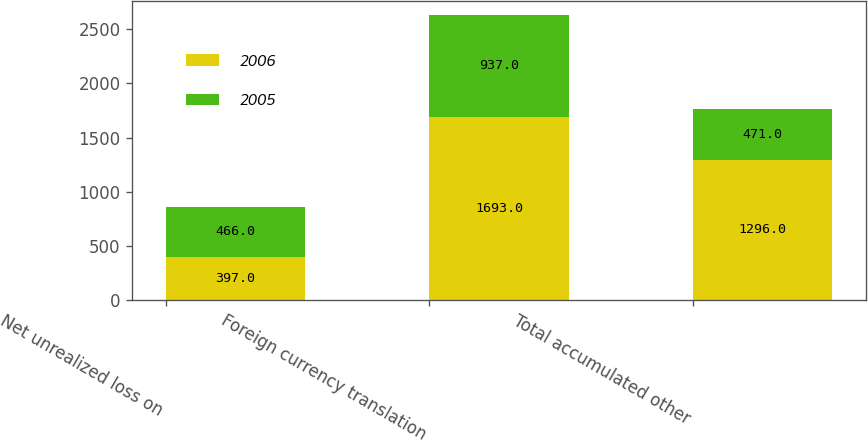Convert chart to OTSL. <chart><loc_0><loc_0><loc_500><loc_500><stacked_bar_chart><ecel><fcel>Net unrealized loss on<fcel>Foreign currency translation<fcel>Total accumulated other<nl><fcel>2006<fcel>397<fcel>1693<fcel>1296<nl><fcel>2005<fcel>466<fcel>937<fcel>471<nl></chart> 